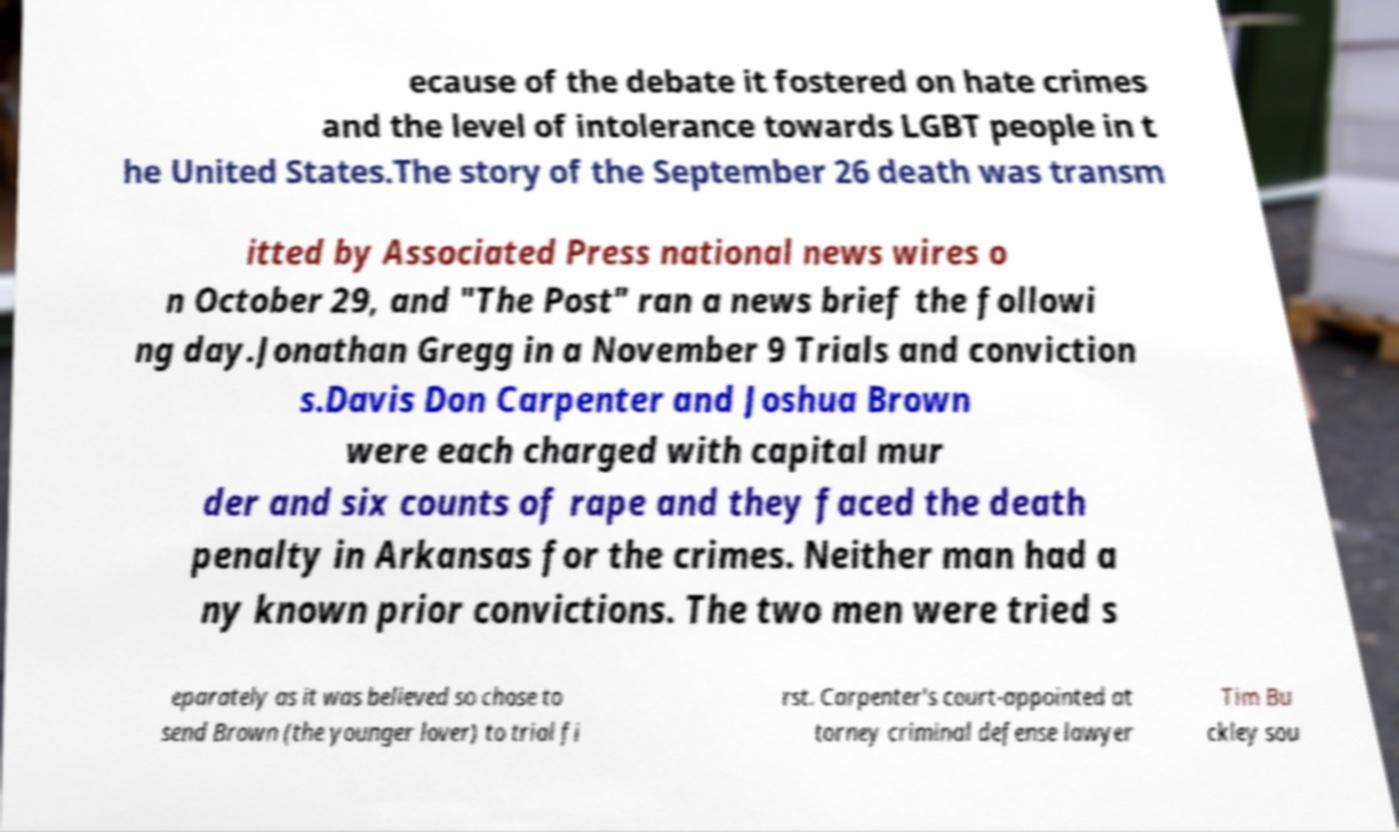What messages or text are displayed in this image? I need them in a readable, typed format. ecause of the debate it fostered on hate crimes and the level of intolerance towards LGBT people in t he United States.The story of the September 26 death was transm itted by Associated Press national news wires o n October 29, and "The Post" ran a news brief the followi ng day.Jonathan Gregg in a November 9 Trials and conviction s.Davis Don Carpenter and Joshua Brown were each charged with capital mur der and six counts of rape and they faced the death penalty in Arkansas for the crimes. Neither man had a ny known prior convictions. The two men were tried s eparately as it was believed so chose to send Brown (the younger lover) to trial fi rst. Carpenter's court-appointed at torney criminal defense lawyer Tim Bu ckley sou 